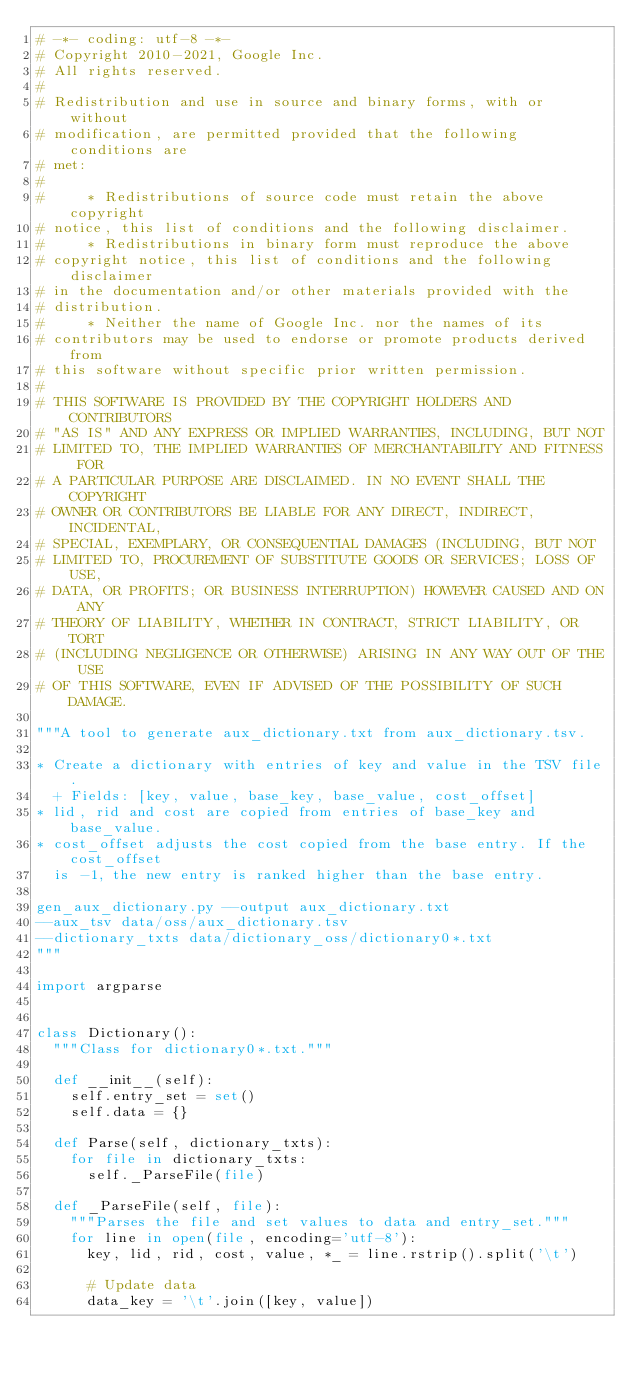Convert code to text. <code><loc_0><loc_0><loc_500><loc_500><_Python_># -*- coding: utf-8 -*-
# Copyright 2010-2021, Google Inc.
# All rights reserved.
#
# Redistribution and use in source and binary forms, with or without
# modification, are permitted provided that the following conditions are
# met:
#
#     * Redistributions of source code must retain the above copyright
# notice, this list of conditions and the following disclaimer.
#     * Redistributions in binary form must reproduce the above
# copyright notice, this list of conditions and the following disclaimer
# in the documentation and/or other materials provided with the
# distribution.
#     * Neither the name of Google Inc. nor the names of its
# contributors may be used to endorse or promote products derived from
# this software without specific prior written permission.
#
# THIS SOFTWARE IS PROVIDED BY THE COPYRIGHT HOLDERS AND CONTRIBUTORS
# "AS IS" AND ANY EXPRESS OR IMPLIED WARRANTIES, INCLUDING, BUT NOT
# LIMITED TO, THE IMPLIED WARRANTIES OF MERCHANTABILITY AND FITNESS FOR
# A PARTICULAR PURPOSE ARE DISCLAIMED. IN NO EVENT SHALL THE COPYRIGHT
# OWNER OR CONTRIBUTORS BE LIABLE FOR ANY DIRECT, INDIRECT, INCIDENTAL,
# SPECIAL, EXEMPLARY, OR CONSEQUENTIAL DAMAGES (INCLUDING, BUT NOT
# LIMITED TO, PROCUREMENT OF SUBSTITUTE GOODS OR SERVICES; LOSS OF USE,
# DATA, OR PROFITS; OR BUSINESS INTERRUPTION) HOWEVER CAUSED AND ON ANY
# THEORY OF LIABILITY, WHETHER IN CONTRACT, STRICT LIABILITY, OR TORT
# (INCLUDING NEGLIGENCE OR OTHERWISE) ARISING IN ANY WAY OUT OF THE USE
# OF THIS SOFTWARE, EVEN IF ADVISED OF THE POSSIBILITY OF SUCH DAMAGE.

"""A tool to generate aux_dictionary.txt from aux_dictionary.tsv.

* Create a dictionary with entries of key and value in the TSV file.
  + Fields: [key, value, base_key, base_value, cost_offset]
* lid, rid and cost are copied from entries of base_key and base_value.
* cost_offset adjusts the cost copied from the base entry. If the cost_offset
  is -1, the new entry is ranked higher than the base entry.

gen_aux_dictionary.py --output aux_dictionary.txt
--aux_tsv data/oss/aux_dictionary.tsv
--dictionary_txts data/dictionary_oss/dictionary0*.txt
"""

import argparse


class Dictionary():
  """Class for dictionary0*.txt."""

  def __init__(self):
    self.entry_set = set()
    self.data = {}

  def Parse(self, dictionary_txts):
    for file in dictionary_txts:
      self._ParseFile(file)

  def _ParseFile(self, file):
    """Parses the file and set values to data and entry_set."""
    for line in open(file, encoding='utf-8'):
      key, lid, rid, cost, value, *_ = line.rstrip().split('\t')

      # Update data
      data_key = '\t'.join([key, value])</code> 